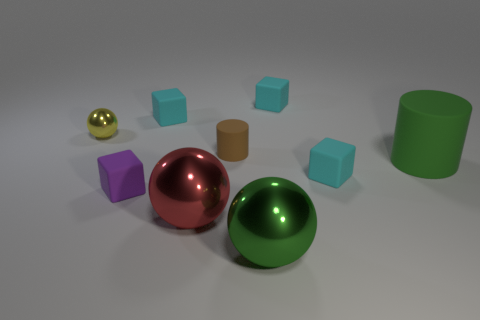Subtract all green spheres. How many cyan cubes are left? 3 Add 1 cylinders. How many objects exist? 10 Subtract all spheres. How many objects are left? 6 Add 3 green matte cylinders. How many green matte cylinders are left? 4 Add 4 tiny balls. How many tiny balls exist? 5 Subtract 1 green balls. How many objects are left? 8 Subtract all small metal balls. Subtract all yellow metallic spheres. How many objects are left? 7 